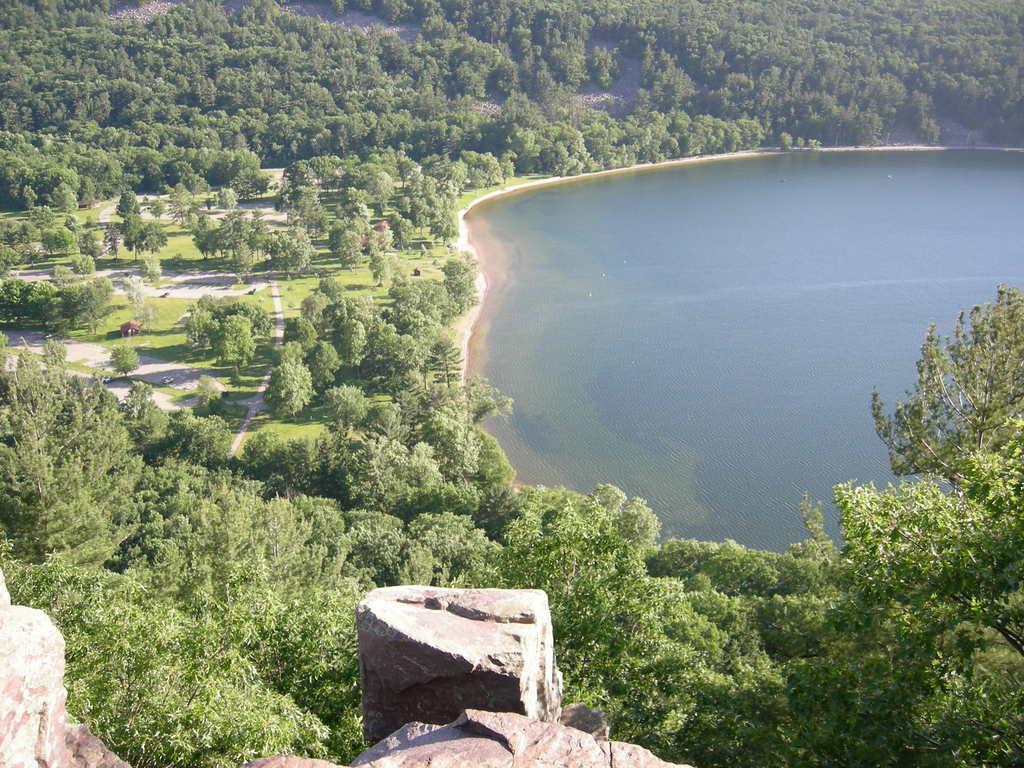Can you describe this image briefly? In this image, we can see some water. There are a few trees, plants. We can see some grass and the ground with some objects. We can also see some stones at the bottom. 